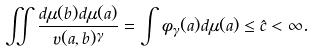<formula> <loc_0><loc_0><loc_500><loc_500>\iint \frac { d \mu ( b ) d \mu ( a ) } { \upsilon ( a , b ) ^ { \gamma } } = \int \phi _ { \gamma } ( a ) d \mu ( a ) \leq \hat { c } < \infty .</formula> 